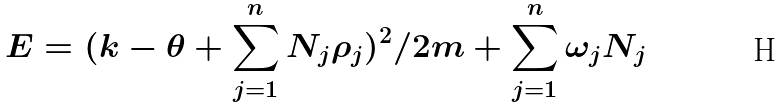<formula> <loc_0><loc_0><loc_500><loc_500>E = ( k - \theta + \sum _ { j = 1 } ^ { n } N _ { j } \rho _ { j } ) ^ { 2 } / 2 m + \sum _ { j = 1 } ^ { n } \omega _ { j } N _ { j }</formula> 